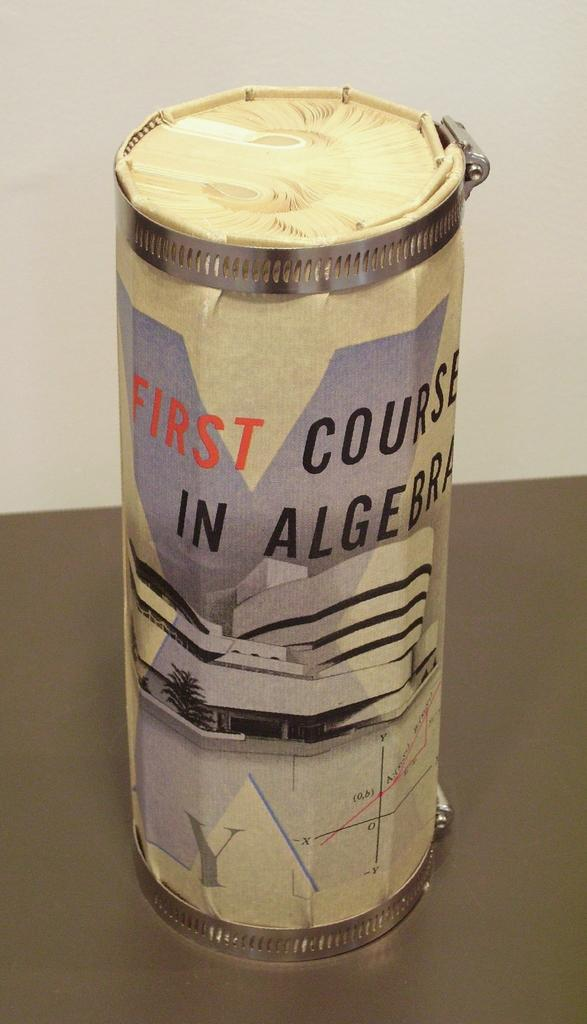<image>
Provide a brief description of the given image. Large can which says "First" in red on the top. 